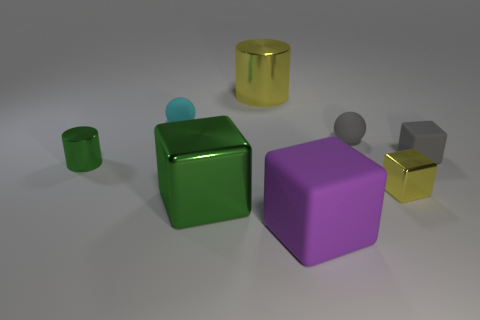Subtract all tiny gray blocks. How many blocks are left? 3 Subtract all green cubes. How many cubes are left? 3 Subtract 2 spheres. How many spheres are left? 0 Subtract 1 gray cubes. How many objects are left? 7 Subtract all cylinders. How many objects are left? 6 Subtract all gray blocks. Subtract all purple cylinders. How many blocks are left? 3 Subtract all green cubes. How many yellow balls are left? 0 Subtract all small cyan objects. Subtract all tiny green cylinders. How many objects are left? 6 Add 7 big things. How many big things are left? 10 Add 2 tiny gray rubber things. How many tiny gray rubber things exist? 4 